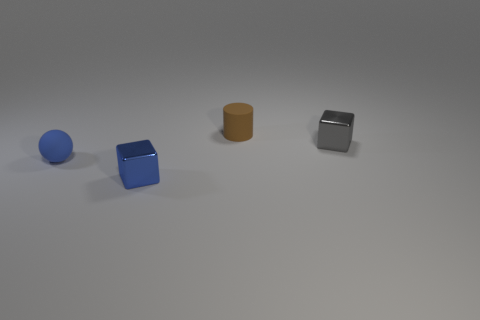How many other things are the same color as the sphere?
Your response must be concise. 1. Are the blue cube and the block that is to the right of the blue shiny thing made of the same material?
Provide a succinct answer. Yes. How many objects are either small metal things that are to the right of the tiny brown cylinder or small blue objects?
Ensure brevity in your answer.  3. What is the shape of the object that is in front of the gray metal block and on the right side of the blue matte thing?
Your response must be concise. Cube. How many things are either matte objects behind the small gray cube or things that are in front of the small gray object?
Your response must be concise. 3. Does the object on the right side of the rubber cylinder have the same size as the small brown rubber thing?
Offer a terse response. Yes. The object that is in front of the tiny blue matte ball is what color?
Make the answer very short. Blue. There is another tiny shiny object that is the same shape as the gray object; what is its color?
Your answer should be very brief. Blue. There is a small blue object that is to the left of the metallic cube to the left of the brown cylinder; how many matte objects are behind it?
Ensure brevity in your answer.  1. Are there any other things that are made of the same material as the brown object?
Give a very brief answer. Yes. 